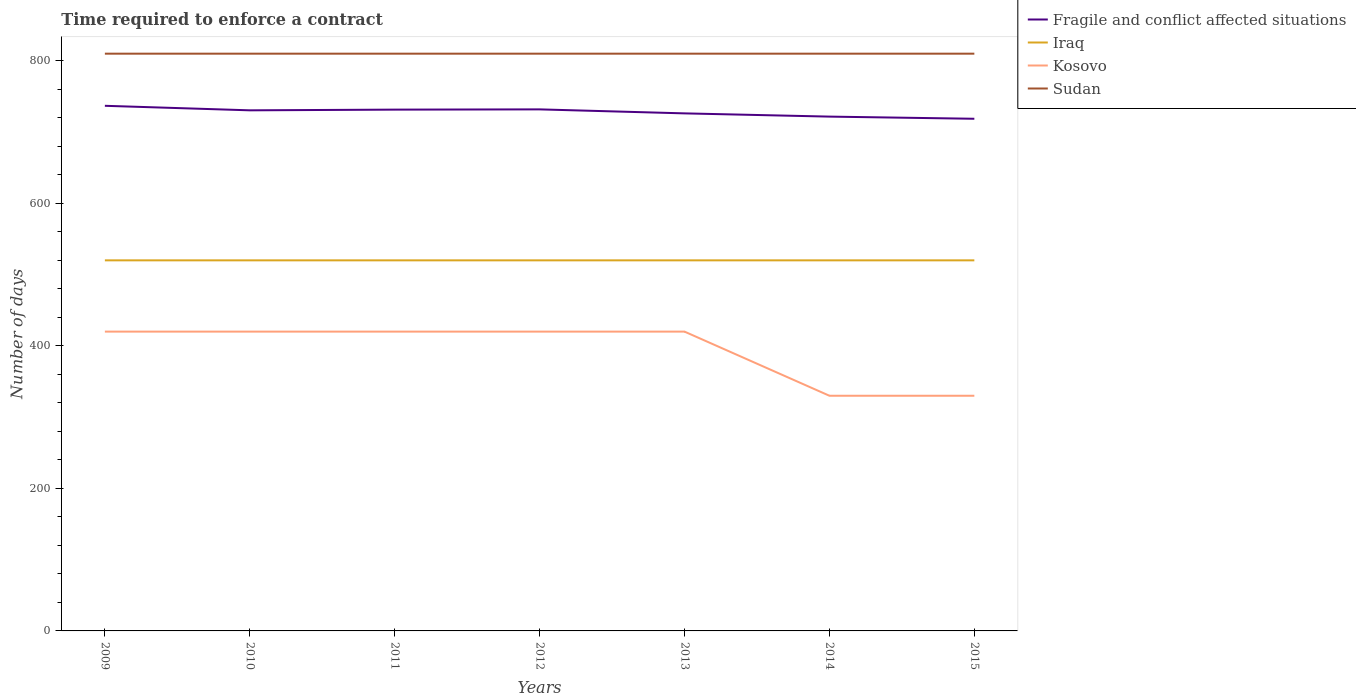Across all years, what is the maximum number of days required to enforce a contract in Iraq?
Keep it short and to the point. 520. In which year was the number of days required to enforce a contract in Fragile and conflict affected situations maximum?
Ensure brevity in your answer.  2015. What is the difference between the highest and the second highest number of days required to enforce a contract in Sudan?
Your answer should be compact. 0. What is the difference between the highest and the lowest number of days required to enforce a contract in Kosovo?
Ensure brevity in your answer.  5. How many lines are there?
Give a very brief answer. 4. What is the difference between two consecutive major ticks on the Y-axis?
Ensure brevity in your answer.  200. Are the values on the major ticks of Y-axis written in scientific E-notation?
Offer a terse response. No. Does the graph contain any zero values?
Keep it short and to the point. No. Where does the legend appear in the graph?
Make the answer very short. Top right. How many legend labels are there?
Offer a terse response. 4. What is the title of the graph?
Your response must be concise. Time required to enforce a contract. What is the label or title of the X-axis?
Your answer should be compact. Years. What is the label or title of the Y-axis?
Your answer should be compact. Number of days. What is the Number of days of Fragile and conflict affected situations in 2009?
Your answer should be very brief. 736.87. What is the Number of days of Iraq in 2009?
Provide a succinct answer. 520. What is the Number of days of Kosovo in 2009?
Your response must be concise. 420. What is the Number of days in Sudan in 2009?
Keep it short and to the point. 810. What is the Number of days in Fragile and conflict affected situations in 2010?
Offer a very short reply. 730.5. What is the Number of days of Iraq in 2010?
Keep it short and to the point. 520. What is the Number of days of Kosovo in 2010?
Provide a short and direct response. 420. What is the Number of days in Sudan in 2010?
Provide a succinct answer. 810. What is the Number of days in Fragile and conflict affected situations in 2011?
Offer a terse response. 731.5. What is the Number of days of Iraq in 2011?
Your answer should be very brief. 520. What is the Number of days in Kosovo in 2011?
Provide a short and direct response. 420. What is the Number of days in Sudan in 2011?
Ensure brevity in your answer.  810. What is the Number of days in Fragile and conflict affected situations in 2012?
Provide a succinct answer. 731.85. What is the Number of days in Iraq in 2012?
Give a very brief answer. 520. What is the Number of days in Kosovo in 2012?
Make the answer very short. 420. What is the Number of days in Sudan in 2012?
Your response must be concise. 810. What is the Number of days of Fragile and conflict affected situations in 2013?
Offer a terse response. 726.24. What is the Number of days in Iraq in 2013?
Your response must be concise. 520. What is the Number of days in Kosovo in 2013?
Offer a very short reply. 420. What is the Number of days in Sudan in 2013?
Your answer should be very brief. 810. What is the Number of days in Fragile and conflict affected situations in 2014?
Offer a very short reply. 721.7. What is the Number of days of Iraq in 2014?
Keep it short and to the point. 520. What is the Number of days of Kosovo in 2014?
Offer a very short reply. 330. What is the Number of days of Sudan in 2014?
Your answer should be very brief. 810. What is the Number of days in Fragile and conflict affected situations in 2015?
Provide a short and direct response. 718.67. What is the Number of days in Iraq in 2015?
Your answer should be compact. 520. What is the Number of days in Kosovo in 2015?
Your answer should be compact. 330. What is the Number of days of Sudan in 2015?
Your answer should be very brief. 810. Across all years, what is the maximum Number of days of Fragile and conflict affected situations?
Provide a succinct answer. 736.87. Across all years, what is the maximum Number of days of Iraq?
Keep it short and to the point. 520. Across all years, what is the maximum Number of days of Kosovo?
Keep it short and to the point. 420. Across all years, what is the maximum Number of days of Sudan?
Keep it short and to the point. 810. Across all years, what is the minimum Number of days in Fragile and conflict affected situations?
Provide a succinct answer. 718.67. Across all years, what is the minimum Number of days in Iraq?
Keep it short and to the point. 520. Across all years, what is the minimum Number of days of Kosovo?
Offer a terse response. 330. Across all years, what is the minimum Number of days in Sudan?
Your answer should be very brief. 810. What is the total Number of days of Fragile and conflict affected situations in the graph?
Your answer should be very brief. 5097.32. What is the total Number of days in Iraq in the graph?
Your answer should be compact. 3640. What is the total Number of days in Kosovo in the graph?
Give a very brief answer. 2760. What is the total Number of days in Sudan in the graph?
Offer a terse response. 5670. What is the difference between the Number of days of Fragile and conflict affected situations in 2009 and that in 2010?
Give a very brief answer. 6.37. What is the difference between the Number of days of Fragile and conflict affected situations in 2009 and that in 2011?
Keep it short and to the point. 5.37. What is the difference between the Number of days of Iraq in 2009 and that in 2011?
Ensure brevity in your answer.  0. What is the difference between the Number of days in Sudan in 2009 and that in 2011?
Your response must be concise. 0. What is the difference between the Number of days of Fragile and conflict affected situations in 2009 and that in 2012?
Make the answer very short. 5.02. What is the difference between the Number of days in Iraq in 2009 and that in 2012?
Offer a very short reply. 0. What is the difference between the Number of days of Kosovo in 2009 and that in 2012?
Keep it short and to the point. 0. What is the difference between the Number of days of Fragile and conflict affected situations in 2009 and that in 2013?
Provide a short and direct response. 10.62. What is the difference between the Number of days in Fragile and conflict affected situations in 2009 and that in 2014?
Offer a terse response. 15.17. What is the difference between the Number of days in Kosovo in 2009 and that in 2014?
Your answer should be very brief. 90. What is the difference between the Number of days of Sudan in 2009 and that in 2014?
Provide a succinct answer. 0. What is the difference between the Number of days in Fragile and conflict affected situations in 2009 and that in 2015?
Your response must be concise. 18.2. What is the difference between the Number of days of Sudan in 2009 and that in 2015?
Your response must be concise. 0. What is the difference between the Number of days of Fragile and conflict affected situations in 2010 and that in 2011?
Your answer should be very brief. -1. What is the difference between the Number of days in Iraq in 2010 and that in 2011?
Provide a short and direct response. 0. What is the difference between the Number of days of Sudan in 2010 and that in 2011?
Provide a succinct answer. 0. What is the difference between the Number of days in Fragile and conflict affected situations in 2010 and that in 2012?
Your response must be concise. -1.35. What is the difference between the Number of days in Iraq in 2010 and that in 2012?
Your answer should be compact. 0. What is the difference between the Number of days in Sudan in 2010 and that in 2012?
Make the answer very short. 0. What is the difference between the Number of days in Fragile and conflict affected situations in 2010 and that in 2013?
Your answer should be very brief. 4.26. What is the difference between the Number of days in Iraq in 2010 and that in 2013?
Your response must be concise. 0. What is the difference between the Number of days of Kosovo in 2010 and that in 2013?
Offer a terse response. 0. What is the difference between the Number of days of Fragile and conflict affected situations in 2010 and that in 2014?
Your response must be concise. 8.8. What is the difference between the Number of days of Iraq in 2010 and that in 2014?
Your response must be concise. 0. What is the difference between the Number of days in Kosovo in 2010 and that in 2014?
Ensure brevity in your answer.  90. What is the difference between the Number of days in Sudan in 2010 and that in 2014?
Offer a terse response. 0. What is the difference between the Number of days of Fragile and conflict affected situations in 2010 and that in 2015?
Offer a very short reply. 11.83. What is the difference between the Number of days of Iraq in 2010 and that in 2015?
Offer a terse response. 0. What is the difference between the Number of days in Fragile and conflict affected situations in 2011 and that in 2012?
Provide a short and direct response. -0.35. What is the difference between the Number of days in Iraq in 2011 and that in 2012?
Give a very brief answer. 0. What is the difference between the Number of days in Sudan in 2011 and that in 2012?
Your answer should be very brief. 0. What is the difference between the Number of days of Fragile and conflict affected situations in 2011 and that in 2013?
Your answer should be compact. 5.26. What is the difference between the Number of days in Iraq in 2011 and that in 2013?
Your answer should be compact. 0. What is the difference between the Number of days of Fragile and conflict affected situations in 2011 and that in 2014?
Your answer should be compact. 9.8. What is the difference between the Number of days of Kosovo in 2011 and that in 2014?
Provide a succinct answer. 90. What is the difference between the Number of days of Sudan in 2011 and that in 2014?
Keep it short and to the point. 0. What is the difference between the Number of days in Fragile and conflict affected situations in 2011 and that in 2015?
Your answer should be compact. 12.83. What is the difference between the Number of days of Kosovo in 2011 and that in 2015?
Ensure brevity in your answer.  90. What is the difference between the Number of days of Sudan in 2011 and that in 2015?
Provide a short and direct response. 0. What is the difference between the Number of days of Fragile and conflict affected situations in 2012 and that in 2013?
Ensure brevity in your answer.  5.61. What is the difference between the Number of days in Kosovo in 2012 and that in 2013?
Offer a very short reply. 0. What is the difference between the Number of days in Sudan in 2012 and that in 2013?
Your answer should be very brief. 0. What is the difference between the Number of days in Fragile and conflict affected situations in 2012 and that in 2014?
Your response must be concise. 10.15. What is the difference between the Number of days of Iraq in 2012 and that in 2014?
Provide a short and direct response. 0. What is the difference between the Number of days of Fragile and conflict affected situations in 2012 and that in 2015?
Ensure brevity in your answer.  13.18. What is the difference between the Number of days of Fragile and conflict affected situations in 2013 and that in 2014?
Your answer should be compact. 4.55. What is the difference between the Number of days in Iraq in 2013 and that in 2014?
Your answer should be very brief. 0. What is the difference between the Number of days in Fragile and conflict affected situations in 2013 and that in 2015?
Keep it short and to the point. 7.58. What is the difference between the Number of days of Fragile and conflict affected situations in 2014 and that in 2015?
Offer a very short reply. 3.03. What is the difference between the Number of days of Iraq in 2014 and that in 2015?
Provide a succinct answer. 0. What is the difference between the Number of days of Sudan in 2014 and that in 2015?
Give a very brief answer. 0. What is the difference between the Number of days of Fragile and conflict affected situations in 2009 and the Number of days of Iraq in 2010?
Give a very brief answer. 216.87. What is the difference between the Number of days of Fragile and conflict affected situations in 2009 and the Number of days of Kosovo in 2010?
Keep it short and to the point. 316.87. What is the difference between the Number of days of Fragile and conflict affected situations in 2009 and the Number of days of Sudan in 2010?
Your answer should be very brief. -73.13. What is the difference between the Number of days in Iraq in 2009 and the Number of days in Sudan in 2010?
Offer a terse response. -290. What is the difference between the Number of days in Kosovo in 2009 and the Number of days in Sudan in 2010?
Make the answer very short. -390. What is the difference between the Number of days in Fragile and conflict affected situations in 2009 and the Number of days in Iraq in 2011?
Provide a short and direct response. 216.87. What is the difference between the Number of days of Fragile and conflict affected situations in 2009 and the Number of days of Kosovo in 2011?
Provide a succinct answer. 316.87. What is the difference between the Number of days in Fragile and conflict affected situations in 2009 and the Number of days in Sudan in 2011?
Give a very brief answer. -73.13. What is the difference between the Number of days of Iraq in 2009 and the Number of days of Sudan in 2011?
Keep it short and to the point. -290. What is the difference between the Number of days in Kosovo in 2009 and the Number of days in Sudan in 2011?
Your answer should be very brief. -390. What is the difference between the Number of days of Fragile and conflict affected situations in 2009 and the Number of days of Iraq in 2012?
Make the answer very short. 216.87. What is the difference between the Number of days of Fragile and conflict affected situations in 2009 and the Number of days of Kosovo in 2012?
Keep it short and to the point. 316.87. What is the difference between the Number of days in Fragile and conflict affected situations in 2009 and the Number of days in Sudan in 2012?
Offer a terse response. -73.13. What is the difference between the Number of days in Iraq in 2009 and the Number of days in Kosovo in 2012?
Provide a succinct answer. 100. What is the difference between the Number of days in Iraq in 2009 and the Number of days in Sudan in 2012?
Provide a short and direct response. -290. What is the difference between the Number of days of Kosovo in 2009 and the Number of days of Sudan in 2012?
Your answer should be very brief. -390. What is the difference between the Number of days in Fragile and conflict affected situations in 2009 and the Number of days in Iraq in 2013?
Ensure brevity in your answer.  216.87. What is the difference between the Number of days in Fragile and conflict affected situations in 2009 and the Number of days in Kosovo in 2013?
Make the answer very short. 316.87. What is the difference between the Number of days of Fragile and conflict affected situations in 2009 and the Number of days of Sudan in 2013?
Your response must be concise. -73.13. What is the difference between the Number of days in Iraq in 2009 and the Number of days in Kosovo in 2013?
Give a very brief answer. 100. What is the difference between the Number of days in Iraq in 2009 and the Number of days in Sudan in 2013?
Offer a very short reply. -290. What is the difference between the Number of days in Kosovo in 2009 and the Number of days in Sudan in 2013?
Provide a succinct answer. -390. What is the difference between the Number of days of Fragile and conflict affected situations in 2009 and the Number of days of Iraq in 2014?
Provide a short and direct response. 216.87. What is the difference between the Number of days of Fragile and conflict affected situations in 2009 and the Number of days of Kosovo in 2014?
Make the answer very short. 406.87. What is the difference between the Number of days in Fragile and conflict affected situations in 2009 and the Number of days in Sudan in 2014?
Your response must be concise. -73.13. What is the difference between the Number of days in Iraq in 2009 and the Number of days in Kosovo in 2014?
Provide a short and direct response. 190. What is the difference between the Number of days in Iraq in 2009 and the Number of days in Sudan in 2014?
Make the answer very short. -290. What is the difference between the Number of days in Kosovo in 2009 and the Number of days in Sudan in 2014?
Provide a short and direct response. -390. What is the difference between the Number of days of Fragile and conflict affected situations in 2009 and the Number of days of Iraq in 2015?
Your answer should be very brief. 216.87. What is the difference between the Number of days in Fragile and conflict affected situations in 2009 and the Number of days in Kosovo in 2015?
Give a very brief answer. 406.87. What is the difference between the Number of days of Fragile and conflict affected situations in 2009 and the Number of days of Sudan in 2015?
Ensure brevity in your answer.  -73.13. What is the difference between the Number of days of Iraq in 2009 and the Number of days of Kosovo in 2015?
Ensure brevity in your answer.  190. What is the difference between the Number of days of Iraq in 2009 and the Number of days of Sudan in 2015?
Offer a very short reply. -290. What is the difference between the Number of days of Kosovo in 2009 and the Number of days of Sudan in 2015?
Ensure brevity in your answer.  -390. What is the difference between the Number of days in Fragile and conflict affected situations in 2010 and the Number of days in Iraq in 2011?
Offer a terse response. 210.5. What is the difference between the Number of days in Fragile and conflict affected situations in 2010 and the Number of days in Kosovo in 2011?
Offer a very short reply. 310.5. What is the difference between the Number of days in Fragile and conflict affected situations in 2010 and the Number of days in Sudan in 2011?
Keep it short and to the point. -79.5. What is the difference between the Number of days of Iraq in 2010 and the Number of days of Kosovo in 2011?
Your answer should be very brief. 100. What is the difference between the Number of days of Iraq in 2010 and the Number of days of Sudan in 2011?
Ensure brevity in your answer.  -290. What is the difference between the Number of days of Kosovo in 2010 and the Number of days of Sudan in 2011?
Give a very brief answer. -390. What is the difference between the Number of days in Fragile and conflict affected situations in 2010 and the Number of days in Iraq in 2012?
Your response must be concise. 210.5. What is the difference between the Number of days in Fragile and conflict affected situations in 2010 and the Number of days in Kosovo in 2012?
Provide a succinct answer. 310.5. What is the difference between the Number of days in Fragile and conflict affected situations in 2010 and the Number of days in Sudan in 2012?
Offer a very short reply. -79.5. What is the difference between the Number of days of Iraq in 2010 and the Number of days of Kosovo in 2012?
Provide a succinct answer. 100. What is the difference between the Number of days of Iraq in 2010 and the Number of days of Sudan in 2012?
Keep it short and to the point. -290. What is the difference between the Number of days in Kosovo in 2010 and the Number of days in Sudan in 2012?
Provide a succinct answer. -390. What is the difference between the Number of days of Fragile and conflict affected situations in 2010 and the Number of days of Iraq in 2013?
Offer a terse response. 210.5. What is the difference between the Number of days in Fragile and conflict affected situations in 2010 and the Number of days in Kosovo in 2013?
Keep it short and to the point. 310.5. What is the difference between the Number of days in Fragile and conflict affected situations in 2010 and the Number of days in Sudan in 2013?
Your response must be concise. -79.5. What is the difference between the Number of days of Iraq in 2010 and the Number of days of Kosovo in 2013?
Give a very brief answer. 100. What is the difference between the Number of days of Iraq in 2010 and the Number of days of Sudan in 2013?
Give a very brief answer. -290. What is the difference between the Number of days of Kosovo in 2010 and the Number of days of Sudan in 2013?
Your response must be concise. -390. What is the difference between the Number of days in Fragile and conflict affected situations in 2010 and the Number of days in Iraq in 2014?
Make the answer very short. 210.5. What is the difference between the Number of days in Fragile and conflict affected situations in 2010 and the Number of days in Kosovo in 2014?
Your answer should be compact. 400.5. What is the difference between the Number of days of Fragile and conflict affected situations in 2010 and the Number of days of Sudan in 2014?
Provide a short and direct response. -79.5. What is the difference between the Number of days in Iraq in 2010 and the Number of days in Kosovo in 2014?
Provide a short and direct response. 190. What is the difference between the Number of days of Iraq in 2010 and the Number of days of Sudan in 2014?
Your response must be concise. -290. What is the difference between the Number of days of Kosovo in 2010 and the Number of days of Sudan in 2014?
Make the answer very short. -390. What is the difference between the Number of days in Fragile and conflict affected situations in 2010 and the Number of days in Iraq in 2015?
Ensure brevity in your answer.  210.5. What is the difference between the Number of days of Fragile and conflict affected situations in 2010 and the Number of days of Kosovo in 2015?
Offer a very short reply. 400.5. What is the difference between the Number of days of Fragile and conflict affected situations in 2010 and the Number of days of Sudan in 2015?
Keep it short and to the point. -79.5. What is the difference between the Number of days of Iraq in 2010 and the Number of days of Kosovo in 2015?
Your answer should be compact. 190. What is the difference between the Number of days in Iraq in 2010 and the Number of days in Sudan in 2015?
Your response must be concise. -290. What is the difference between the Number of days of Kosovo in 2010 and the Number of days of Sudan in 2015?
Make the answer very short. -390. What is the difference between the Number of days in Fragile and conflict affected situations in 2011 and the Number of days in Iraq in 2012?
Your response must be concise. 211.5. What is the difference between the Number of days of Fragile and conflict affected situations in 2011 and the Number of days of Kosovo in 2012?
Provide a succinct answer. 311.5. What is the difference between the Number of days of Fragile and conflict affected situations in 2011 and the Number of days of Sudan in 2012?
Your response must be concise. -78.5. What is the difference between the Number of days in Iraq in 2011 and the Number of days in Kosovo in 2012?
Your answer should be very brief. 100. What is the difference between the Number of days in Iraq in 2011 and the Number of days in Sudan in 2012?
Make the answer very short. -290. What is the difference between the Number of days of Kosovo in 2011 and the Number of days of Sudan in 2012?
Your response must be concise. -390. What is the difference between the Number of days of Fragile and conflict affected situations in 2011 and the Number of days of Iraq in 2013?
Your answer should be compact. 211.5. What is the difference between the Number of days in Fragile and conflict affected situations in 2011 and the Number of days in Kosovo in 2013?
Your response must be concise. 311.5. What is the difference between the Number of days of Fragile and conflict affected situations in 2011 and the Number of days of Sudan in 2013?
Offer a very short reply. -78.5. What is the difference between the Number of days of Iraq in 2011 and the Number of days of Kosovo in 2013?
Your answer should be compact. 100. What is the difference between the Number of days of Iraq in 2011 and the Number of days of Sudan in 2013?
Keep it short and to the point. -290. What is the difference between the Number of days of Kosovo in 2011 and the Number of days of Sudan in 2013?
Make the answer very short. -390. What is the difference between the Number of days in Fragile and conflict affected situations in 2011 and the Number of days in Iraq in 2014?
Ensure brevity in your answer.  211.5. What is the difference between the Number of days of Fragile and conflict affected situations in 2011 and the Number of days of Kosovo in 2014?
Give a very brief answer. 401.5. What is the difference between the Number of days in Fragile and conflict affected situations in 2011 and the Number of days in Sudan in 2014?
Offer a very short reply. -78.5. What is the difference between the Number of days of Iraq in 2011 and the Number of days of Kosovo in 2014?
Keep it short and to the point. 190. What is the difference between the Number of days in Iraq in 2011 and the Number of days in Sudan in 2014?
Provide a short and direct response. -290. What is the difference between the Number of days in Kosovo in 2011 and the Number of days in Sudan in 2014?
Offer a very short reply. -390. What is the difference between the Number of days of Fragile and conflict affected situations in 2011 and the Number of days of Iraq in 2015?
Provide a short and direct response. 211.5. What is the difference between the Number of days of Fragile and conflict affected situations in 2011 and the Number of days of Kosovo in 2015?
Your answer should be compact. 401.5. What is the difference between the Number of days of Fragile and conflict affected situations in 2011 and the Number of days of Sudan in 2015?
Make the answer very short. -78.5. What is the difference between the Number of days of Iraq in 2011 and the Number of days of Kosovo in 2015?
Offer a very short reply. 190. What is the difference between the Number of days of Iraq in 2011 and the Number of days of Sudan in 2015?
Your answer should be compact. -290. What is the difference between the Number of days in Kosovo in 2011 and the Number of days in Sudan in 2015?
Your response must be concise. -390. What is the difference between the Number of days of Fragile and conflict affected situations in 2012 and the Number of days of Iraq in 2013?
Make the answer very short. 211.85. What is the difference between the Number of days in Fragile and conflict affected situations in 2012 and the Number of days in Kosovo in 2013?
Provide a short and direct response. 311.85. What is the difference between the Number of days of Fragile and conflict affected situations in 2012 and the Number of days of Sudan in 2013?
Keep it short and to the point. -78.15. What is the difference between the Number of days in Iraq in 2012 and the Number of days in Sudan in 2013?
Provide a succinct answer. -290. What is the difference between the Number of days in Kosovo in 2012 and the Number of days in Sudan in 2013?
Offer a very short reply. -390. What is the difference between the Number of days of Fragile and conflict affected situations in 2012 and the Number of days of Iraq in 2014?
Your answer should be very brief. 211.85. What is the difference between the Number of days of Fragile and conflict affected situations in 2012 and the Number of days of Kosovo in 2014?
Keep it short and to the point. 401.85. What is the difference between the Number of days in Fragile and conflict affected situations in 2012 and the Number of days in Sudan in 2014?
Ensure brevity in your answer.  -78.15. What is the difference between the Number of days of Iraq in 2012 and the Number of days of Kosovo in 2014?
Ensure brevity in your answer.  190. What is the difference between the Number of days in Iraq in 2012 and the Number of days in Sudan in 2014?
Give a very brief answer. -290. What is the difference between the Number of days of Kosovo in 2012 and the Number of days of Sudan in 2014?
Your response must be concise. -390. What is the difference between the Number of days in Fragile and conflict affected situations in 2012 and the Number of days in Iraq in 2015?
Ensure brevity in your answer.  211.85. What is the difference between the Number of days in Fragile and conflict affected situations in 2012 and the Number of days in Kosovo in 2015?
Your answer should be very brief. 401.85. What is the difference between the Number of days in Fragile and conflict affected situations in 2012 and the Number of days in Sudan in 2015?
Offer a terse response. -78.15. What is the difference between the Number of days of Iraq in 2012 and the Number of days of Kosovo in 2015?
Ensure brevity in your answer.  190. What is the difference between the Number of days of Iraq in 2012 and the Number of days of Sudan in 2015?
Give a very brief answer. -290. What is the difference between the Number of days of Kosovo in 2012 and the Number of days of Sudan in 2015?
Offer a terse response. -390. What is the difference between the Number of days in Fragile and conflict affected situations in 2013 and the Number of days in Iraq in 2014?
Keep it short and to the point. 206.24. What is the difference between the Number of days of Fragile and conflict affected situations in 2013 and the Number of days of Kosovo in 2014?
Provide a succinct answer. 396.24. What is the difference between the Number of days in Fragile and conflict affected situations in 2013 and the Number of days in Sudan in 2014?
Make the answer very short. -83.76. What is the difference between the Number of days in Iraq in 2013 and the Number of days in Kosovo in 2014?
Ensure brevity in your answer.  190. What is the difference between the Number of days in Iraq in 2013 and the Number of days in Sudan in 2014?
Give a very brief answer. -290. What is the difference between the Number of days in Kosovo in 2013 and the Number of days in Sudan in 2014?
Your answer should be compact. -390. What is the difference between the Number of days in Fragile and conflict affected situations in 2013 and the Number of days in Iraq in 2015?
Your answer should be very brief. 206.24. What is the difference between the Number of days of Fragile and conflict affected situations in 2013 and the Number of days of Kosovo in 2015?
Provide a short and direct response. 396.24. What is the difference between the Number of days of Fragile and conflict affected situations in 2013 and the Number of days of Sudan in 2015?
Make the answer very short. -83.76. What is the difference between the Number of days in Iraq in 2013 and the Number of days in Kosovo in 2015?
Your answer should be compact. 190. What is the difference between the Number of days in Iraq in 2013 and the Number of days in Sudan in 2015?
Make the answer very short. -290. What is the difference between the Number of days in Kosovo in 2013 and the Number of days in Sudan in 2015?
Ensure brevity in your answer.  -390. What is the difference between the Number of days in Fragile and conflict affected situations in 2014 and the Number of days in Iraq in 2015?
Make the answer very short. 201.7. What is the difference between the Number of days of Fragile and conflict affected situations in 2014 and the Number of days of Kosovo in 2015?
Ensure brevity in your answer.  391.7. What is the difference between the Number of days of Fragile and conflict affected situations in 2014 and the Number of days of Sudan in 2015?
Your answer should be very brief. -88.3. What is the difference between the Number of days in Iraq in 2014 and the Number of days in Kosovo in 2015?
Your response must be concise. 190. What is the difference between the Number of days of Iraq in 2014 and the Number of days of Sudan in 2015?
Keep it short and to the point. -290. What is the difference between the Number of days in Kosovo in 2014 and the Number of days in Sudan in 2015?
Offer a very short reply. -480. What is the average Number of days of Fragile and conflict affected situations per year?
Make the answer very short. 728.19. What is the average Number of days in Iraq per year?
Make the answer very short. 520. What is the average Number of days of Kosovo per year?
Ensure brevity in your answer.  394.29. What is the average Number of days in Sudan per year?
Keep it short and to the point. 810. In the year 2009, what is the difference between the Number of days of Fragile and conflict affected situations and Number of days of Iraq?
Ensure brevity in your answer.  216.87. In the year 2009, what is the difference between the Number of days in Fragile and conflict affected situations and Number of days in Kosovo?
Ensure brevity in your answer.  316.87. In the year 2009, what is the difference between the Number of days in Fragile and conflict affected situations and Number of days in Sudan?
Make the answer very short. -73.13. In the year 2009, what is the difference between the Number of days of Iraq and Number of days of Kosovo?
Offer a terse response. 100. In the year 2009, what is the difference between the Number of days in Iraq and Number of days in Sudan?
Offer a very short reply. -290. In the year 2009, what is the difference between the Number of days of Kosovo and Number of days of Sudan?
Provide a short and direct response. -390. In the year 2010, what is the difference between the Number of days of Fragile and conflict affected situations and Number of days of Iraq?
Ensure brevity in your answer.  210.5. In the year 2010, what is the difference between the Number of days of Fragile and conflict affected situations and Number of days of Kosovo?
Provide a short and direct response. 310.5. In the year 2010, what is the difference between the Number of days in Fragile and conflict affected situations and Number of days in Sudan?
Provide a succinct answer. -79.5. In the year 2010, what is the difference between the Number of days in Iraq and Number of days in Kosovo?
Keep it short and to the point. 100. In the year 2010, what is the difference between the Number of days in Iraq and Number of days in Sudan?
Offer a very short reply. -290. In the year 2010, what is the difference between the Number of days in Kosovo and Number of days in Sudan?
Keep it short and to the point. -390. In the year 2011, what is the difference between the Number of days of Fragile and conflict affected situations and Number of days of Iraq?
Offer a terse response. 211.5. In the year 2011, what is the difference between the Number of days of Fragile and conflict affected situations and Number of days of Kosovo?
Offer a very short reply. 311.5. In the year 2011, what is the difference between the Number of days of Fragile and conflict affected situations and Number of days of Sudan?
Keep it short and to the point. -78.5. In the year 2011, what is the difference between the Number of days of Iraq and Number of days of Sudan?
Keep it short and to the point. -290. In the year 2011, what is the difference between the Number of days in Kosovo and Number of days in Sudan?
Your answer should be compact. -390. In the year 2012, what is the difference between the Number of days in Fragile and conflict affected situations and Number of days in Iraq?
Give a very brief answer. 211.85. In the year 2012, what is the difference between the Number of days of Fragile and conflict affected situations and Number of days of Kosovo?
Your answer should be compact. 311.85. In the year 2012, what is the difference between the Number of days in Fragile and conflict affected situations and Number of days in Sudan?
Make the answer very short. -78.15. In the year 2012, what is the difference between the Number of days of Iraq and Number of days of Kosovo?
Your answer should be very brief. 100. In the year 2012, what is the difference between the Number of days in Iraq and Number of days in Sudan?
Ensure brevity in your answer.  -290. In the year 2012, what is the difference between the Number of days of Kosovo and Number of days of Sudan?
Keep it short and to the point. -390. In the year 2013, what is the difference between the Number of days in Fragile and conflict affected situations and Number of days in Iraq?
Offer a very short reply. 206.24. In the year 2013, what is the difference between the Number of days of Fragile and conflict affected situations and Number of days of Kosovo?
Offer a terse response. 306.24. In the year 2013, what is the difference between the Number of days in Fragile and conflict affected situations and Number of days in Sudan?
Make the answer very short. -83.76. In the year 2013, what is the difference between the Number of days of Iraq and Number of days of Kosovo?
Give a very brief answer. 100. In the year 2013, what is the difference between the Number of days of Iraq and Number of days of Sudan?
Provide a succinct answer. -290. In the year 2013, what is the difference between the Number of days of Kosovo and Number of days of Sudan?
Offer a terse response. -390. In the year 2014, what is the difference between the Number of days of Fragile and conflict affected situations and Number of days of Iraq?
Your answer should be compact. 201.7. In the year 2014, what is the difference between the Number of days in Fragile and conflict affected situations and Number of days in Kosovo?
Make the answer very short. 391.7. In the year 2014, what is the difference between the Number of days in Fragile and conflict affected situations and Number of days in Sudan?
Your answer should be very brief. -88.3. In the year 2014, what is the difference between the Number of days in Iraq and Number of days in Kosovo?
Your response must be concise. 190. In the year 2014, what is the difference between the Number of days of Iraq and Number of days of Sudan?
Offer a terse response. -290. In the year 2014, what is the difference between the Number of days in Kosovo and Number of days in Sudan?
Provide a succinct answer. -480. In the year 2015, what is the difference between the Number of days of Fragile and conflict affected situations and Number of days of Iraq?
Your response must be concise. 198.67. In the year 2015, what is the difference between the Number of days of Fragile and conflict affected situations and Number of days of Kosovo?
Offer a very short reply. 388.67. In the year 2015, what is the difference between the Number of days of Fragile and conflict affected situations and Number of days of Sudan?
Offer a terse response. -91.33. In the year 2015, what is the difference between the Number of days in Iraq and Number of days in Kosovo?
Provide a succinct answer. 190. In the year 2015, what is the difference between the Number of days of Iraq and Number of days of Sudan?
Provide a short and direct response. -290. In the year 2015, what is the difference between the Number of days in Kosovo and Number of days in Sudan?
Ensure brevity in your answer.  -480. What is the ratio of the Number of days of Fragile and conflict affected situations in 2009 to that in 2010?
Your response must be concise. 1.01. What is the ratio of the Number of days in Iraq in 2009 to that in 2010?
Offer a very short reply. 1. What is the ratio of the Number of days in Kosovo in 2009 to that in 2010?
Your answer should be very brief. 1. What is the ratio of the Number of days of Sudan in 2009 to that in 2010?
Make the answer very short. 1. What is the ratio of the Number of days in Fragile and conflict affected situations in 2009 to that in 2011?
Your answer should be compact. 1.01. What is the ratio of the Number of days of Iraq in 2009 to that in 2011?
Provide a succinct answer. 1. What is the ratio of the Number of days in Kosovo in 2009 to that in 2011?
Your response must be concise. 1. What is the ratio of the Number of days in Sudan in 2009 to that in 2011?
Your answer should be compact. 1. What is the ratio of the Number of days in Fragile and conflict affected situations in 2009 to that in 2012?
Your answer should be very brief. 1.01. What is the ratio of the Number of days in Iraq in 2009 to that in 2012?
Give a very brief answer. 1. What is the ratio of the Number of days of Fragile and conflict affected situations in 2009 to that in 2013?
Provide a succinct answer. 1.01. What is the ratio of the Number of days in Kosovo in 2009 to that in 2013?
Your answer should be compact. 1. What is the ratio of the Number of days in Iraq in 2009 to that in 2014?
Offer a terse response. 1. What is the ratio of the Number of days of Kosovo in 2009 to that in 2014?
Keep it short and to the point. 1.27. What is the ratio of the Number of days in Sudan in 2009 to that in 2014?
Ensure brevity in your answer.  1. What is the ratio of the Number of days of Fragile and conflict affected situations in 2009 to that in 2015?
Ensure brevity in your answer.  1.03. What is the ratio of the Number of days of Kosovo in 2009 to that in 2015?
Your answer should be very brief. 1.27. What is the ratio of the Number of days of Sudan in 2009 to that in 2015?
Make the answer very short. 1. What is the ratio of the Number of days in Kosovo in 2010 to that in 2011?
Provide a succinct answer. 1. What is the ratio of the Number of days in Sudan in 2010 to that in 2011?
Ensure brevity in your answer.  1. What is the ratio of the Number of days in Kosovo in 2010 to that in 2012?
Your response must be concise. 1. What is the ratio of the Number of days in Fragile and conflict affected situations in 2010 to that in 2013?
Provide a succinct answer. 1.01. What is the ratio of the Number of days of Fragile and conflict affected situations in 2010 to that in 2014?
Make the answer very short. 1.01. What is the ratio of the Number of days of Iraq in 2010 to that in 2014?
Give a very brief answer. 1. What is the ratio of the Number of days of Kosovo in 2010 to that in 2014?
Offer a very short reply. 1.27. What is the ratio of the Number of days in Fragile and conflict affected situations in 2010 to that in 2015?
Offer a very short reply. 1.02. What is the ratio of the Number of days of Kosovo in 2010 to that in 2015?
Give a very brief answer. 1.27. What is the ratio of the Number of days in Sudan in 2010 to that in 2015?
Keep it short and to the point. 1. What is the ratio of the Number of days in Fragile and conflict affected situations in 2011 to that in 2013?
Ensure brevity in your answer.  1.01. What is the ratio of the Number of days in Iraq in 2011 to that in 2013?
Ensure brevity in your answer.  1. What is the ratio of the Number of days of Kosovo in 2011 to that in 2013?
Your answer should be very brief. 1. What is the ratio of the Number of days in Fragile and conflict affected situations in 2011 to that in 2014?
Your response must be concise. 1.01. What is the ratio of the Number of days of Iraq in 2011 to that in 2014?
Your answer should be very brief. 1. What is the ratio of the Number of days in Kosovo in 2011 to that in 2014?
Ensure brevity in your answer.  1.27. What is the ratio of the Number of days in Fragile and conflict affected situations in 2011 to that in 2015?
Keep it short and to the point. 1.02. What is the ratio of the Number of days of Kosovo in 2011 to that in 2015?
Offer a terse response. 1.27. What is the ratio of the Number of days of Fragile and conflict affected situations in 2012 to that in 2013?
Your response must be concise. 1.01. What is the ratio of the Number of days of Iraq in 2012 to that in 2013?
Provide a short and direct response. 1. What is the ratio of the Number of days in Sudan in 2012 to that in 2013?
Offer a very short reply. 1. What is the ratio of the Number of days of Fragile and conflict affected situations in 2012 to that in 2014?
Offer a very short reply. 1.01. What is the ratio of the Number of days in Kosovo in 2012 to that in 2014?
Your answer should be compact. 1.27. What is the ratio of the Number of days in Sudan in 2012 to that in 2014?
Offer a terse response. 1. What is the ratio of the Number of days of Fragile and conflict affected situations in 2012 to that in 2015?
Your answer should be very brief. 1.02. What is the ratio of the Number of days in Kosovo in 2012 to that in 2015?
Keep it short and to the point. 1.27. What is the ratio of the Number of days in Sudan in 2012 to that in 2015?
Offer a terse response. 1. What is the ratio of the Number of days in Fragile and conflict affected situations in 2013 to that in 2014?
Ensure brevity in your answer.  1.01. What is the ratio of the Number of days in Kosovo in 2013 to that in 2014?
Offer a very short reply. 1.27. What is the ratio of the Number of days in Fragile and conflict affected situations in 2013 to that in 2015?
Your response must be concise. 1.01. What is the ratio of the Number of days of Iraq in 2013 to that in 2015?
Offer a terse response. 1. What is the ratio of the Number of days of Kosovo in 2013 to that in 2015?
Offer a terse response. 1.27. What is the ratio of the Number of days of Fragile and conflict affected situations in 2014 to that in 2015?
Ensure brevity in your answer.  1. What is the ratio of the Number of days in Iraq in 2014 to that in 2015?
Give a very brief answer. 1. What is the ratio of the Number of days of Kosovo in 2014 to that in 2015?
Your answer should be compact. 1. What is the ratio of the Number of days of Sudan in 2014 to that in 2015?
Keep it short and to the point. 1. What is the difference between the highest and the second highest Number of days in Fragile and conflict affected situations?
Give a very brief answer. 5.02. What is the difference between the highest and the second highest Number of days of Iraq?
Provide a succinct answer. 0. What is the difference between the highest and the second highest Number of days in Kosovo?
Ensure brevity in your answer.  0. What is the difference between the highest and the second highest Number of days of Sudan?
Your answer should be very brief. 0. What is the difference between the highest and the lowest Number of days in Fragile and conflict affected situations?
Make the answer very short. 18.2. What is the difference between the highest and the lowest Number of days in Iraq?
Your response must be concise. 0. What is the difference between the highest and the lowest Number of days in Kosovo?
Offer a very short reply. 90. What is the difference between the highest and the lowest Number of days in Sudan?
Your answer should be compact. 0. 